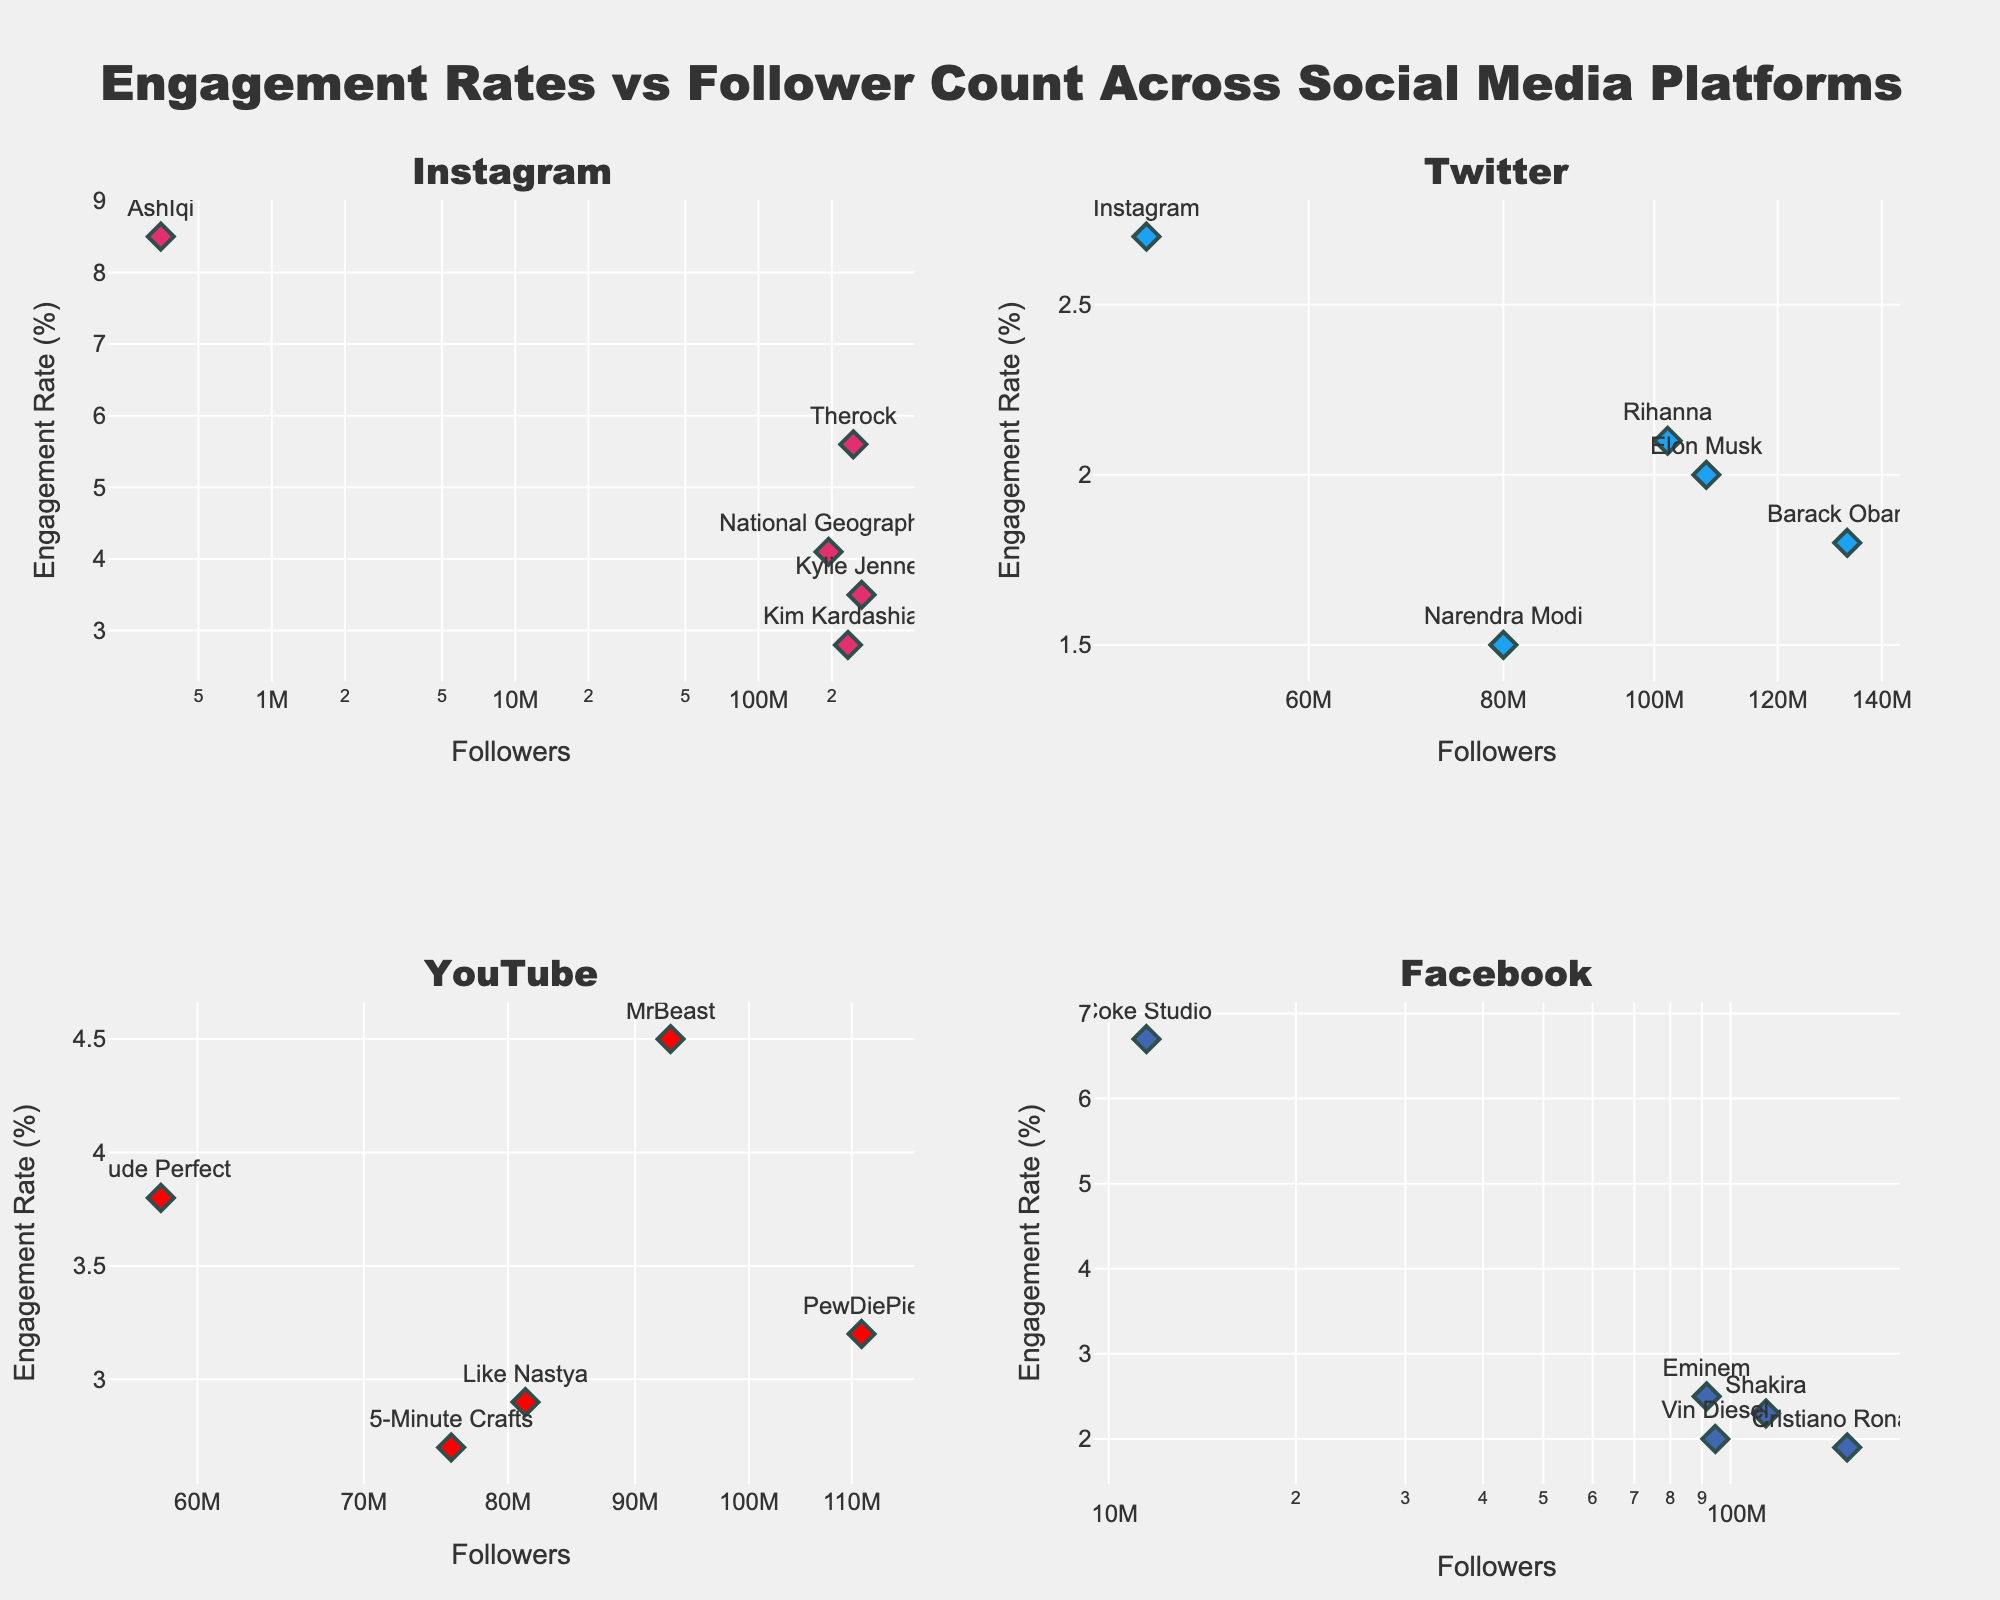What is the platform with the highest engagement rate overall? By observing all the subplots, the highest engagement rate appears in the Facebook subplot with Coke Studio having a 6.7% engagement rate.
Answer: Facebook Which user has the highest number of followers on Instagram? Looking at the Instagram subplot, the user with the highest number of followers is Kylie Jenner with 265,000,000 followers.
Answer: Kylie Jenner What is the average engagement rate for Twitter users in the subplot? Calculate the average of the engagement rates for the Twitter users: (2.0 + 1.8 + 1.5 + 2.7 + 2.1) / 5. This sums up to 10.1, and the average is 10.1/5 = 2.02%.
Answer: 2.02% Who has a better engagement rate, Shakira on Facebook or Kim Kardashian on Instagram? Shakira on Facebook has an engagement rate of 2.3%, while Kim Kardashian on Instagram has an engagement rate of 2.8%.
Answer: Kim Kardashian How does the engagement rate of MrBeast on YouTube compare to that of the average engagement rate of Instagram users? First, calculate the average engagement rate of Instagram users: (3.5 + 2.8 + 4.1 + 5.6 + 8.5) / 5 = 24.5 / 5 = 4.9%. MrBeast has an engagement rate of 4.5% on YouTube, which is slightly less than the Instagram users' average.
Answer: MrBeast has a slightly lower engagement rate than the Instagram average What is the engagement rate of the user with the lowest follower count on Instagram, and who is that user? In the Instagram subplot, the user with the lowest follower count is AshIqi with 350,000 followers and an engagement rate of 8.5%.
Answer: 8.5% (AshIqi) Compare the engagement rates of National Geographic on Instagram and PewDiePie on YouTube. National Geographic on Instagram has an engagement rate of 4.1%, while PewDiePie on YouTube has an engagement rate of 3.2%.
Answer: National Geographic has a higher engagement rate What is the combined follower count of the top two most-followed users on Twitter? The top two most-followed Twitter users are Barack Obama (133,000,000) and Elon Musk (108,000,000). Combined, they have 133,000,000 + 108,000,000 = 241,000,000 followers.
Answer: 241 million Is there a trend between follower count and engagement rate for Facebook users? By reviewing the Facebook subplot, there seems to be no clear trend as the engagement rates and follower counts vary without a consistent pattern.
Answer: No clear trend 